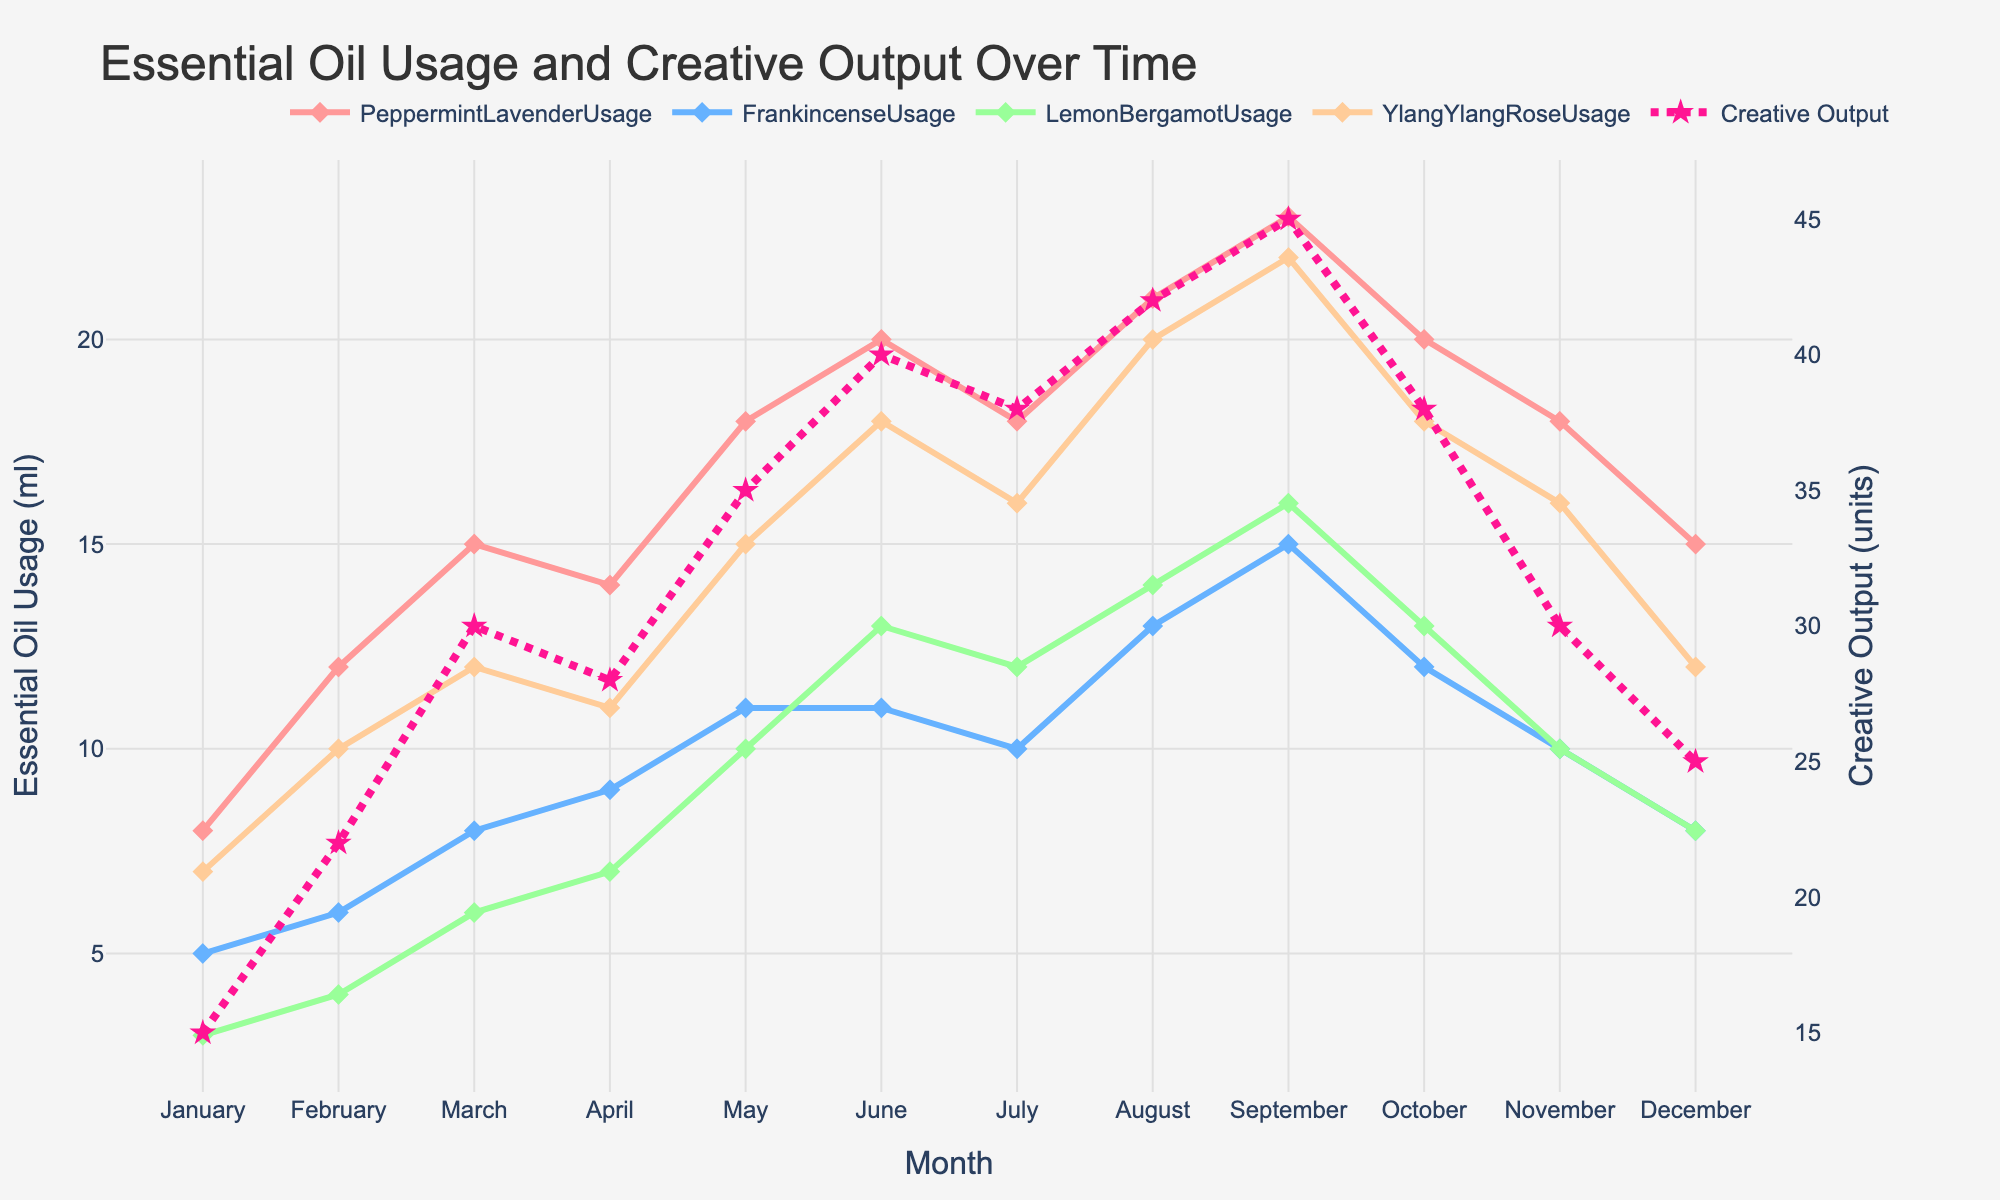What is the trend in Creative Output over the year? The Creative Output shows an overall increasing trend from January to September, peaking at 45 units in September, before decreasing towards December.
Answer: Increasing then decreasing Which month has the highest usage of Peppermint Lavender? The Peppermint Lavender usage is highest in September with 23 ml.
Answer: September How many units of Creative Output were produced in June? The plot shows that the Creative Output in June is 40 units.
Answer: 40 What are the months with the least and highest Creative Output? The Creative Output is least in January with 15 units and highest in September with 45 units.
Answer: January, September Compare the usage of Peppermint Lavender and Frankincense in October. Which is higher? In October, Peppermint Lavender usage is 20 ml, while Frankincense usage is 12 ml. Peppermint Lavender usage is higher.
Answer: Peppermint Lavender Is there a month where the usage of Lemon Bergamot is exactly 10 ml? According to the plot, Lemon Bergamot usage is exactly 10 ml in May.
Answer: May What is the average usage of Ylang Ylang Rose in the first quarter of the year? The usage of Ylang Ylang Rose in the first quarter (January, February, March) is 7, 10, and 12 ml respectively. The average is (7+10+12)/3 = 9.67 ml.
Answer: 9.67 ml During which months is Creative Output above 35 units? Creative Output is above 35 units in May, June, July, August, and September.
Answer: May, June, July, August, September Is there a correlation between the usage of Peppermint Lavender and Creative Output? By visually analyzing the plot, an increase in the usage of Peppermint Lavender generally corresponds to an increase in Creative Output, indicating a positive correlation.
Answer: Positive correlation 